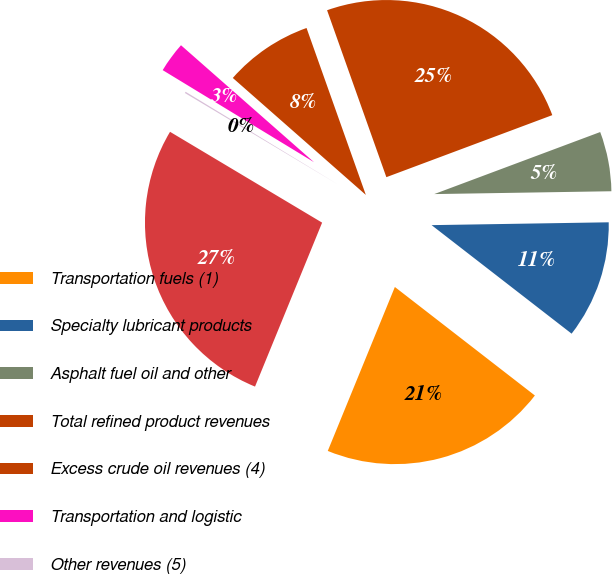Convert chart to OTSL. <chart><loc_0><loc_0><loc_500><loc_500><pie_chart><fcel>Transportation fuels (1)<fcel>Specialty lubricant products<fcel>Asphalt fuel oil and other<fcel>Total refined product revenues<fcel>Excess crude oil revenues (4)<fcel>Transportation and logistic<fcel>Other revenues (5)<fcel>Total sales and other revenues<nl><fcel>20.69%<fcel>10.75%<fcel>5.44%<fcel>24.74%<fcel>8.09%<fcel>2.78%<fcel>0.13%<fcel>27.39%<nl></chart> 